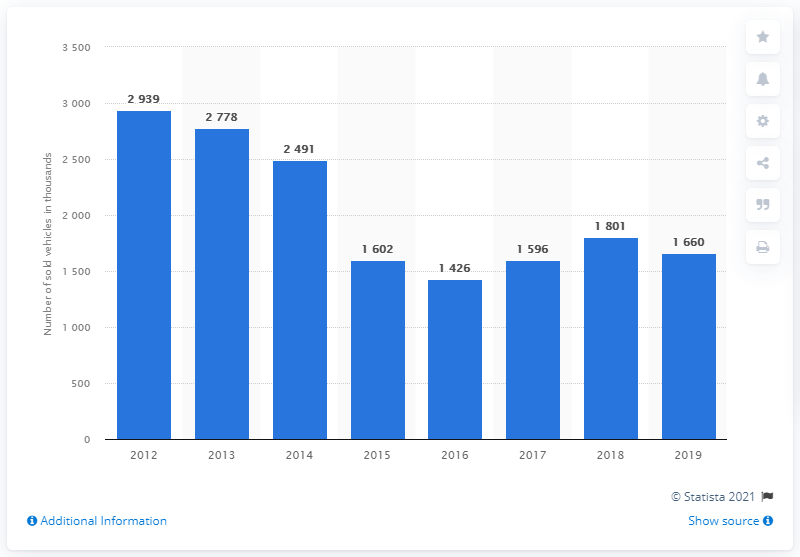Identify some key points in this picture. Since 2012, passenger cars and LCVs have been on a declining trend in Russia. 